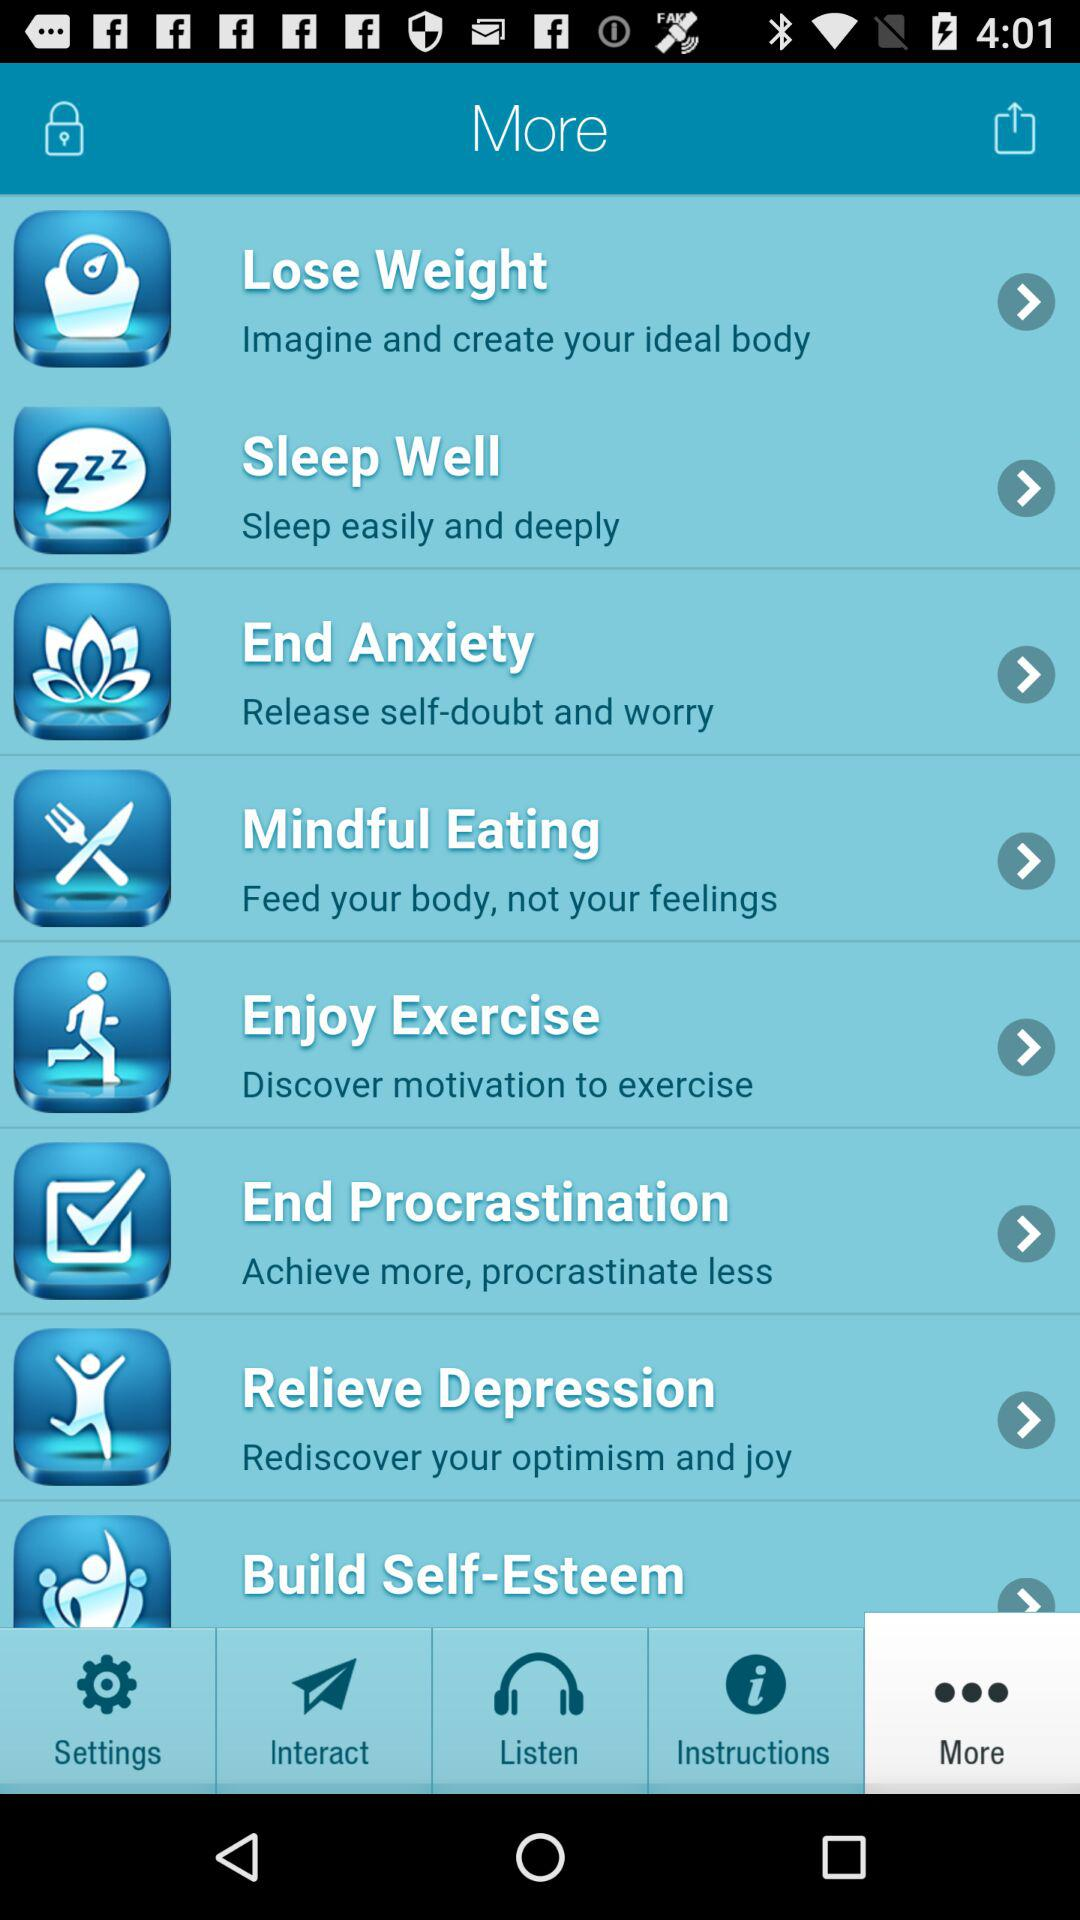Which is the selected tab? The selected tab is "More". 